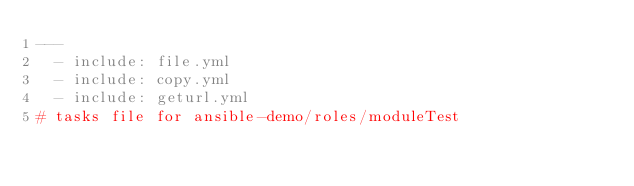Convert code to text. <code><loc_0><loc_0><loc_500><loc_500><_YAML_>---
  - include: file.yml
  - include: copy.yml
  - include: geturl.yml
# tasks file for ansible-demo/roles/moduleTest
</code> 